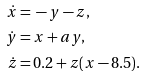Convert formula to latex. <formula><loc_0><loc_0><loc_500><loc_500>\dot { x } = & \, - y - z , \\ \dot { y } = & \, x + a y , \\ \dot { z } = & \, 0 . 2 + z ( x - 8 . 5 ) .</formula> 